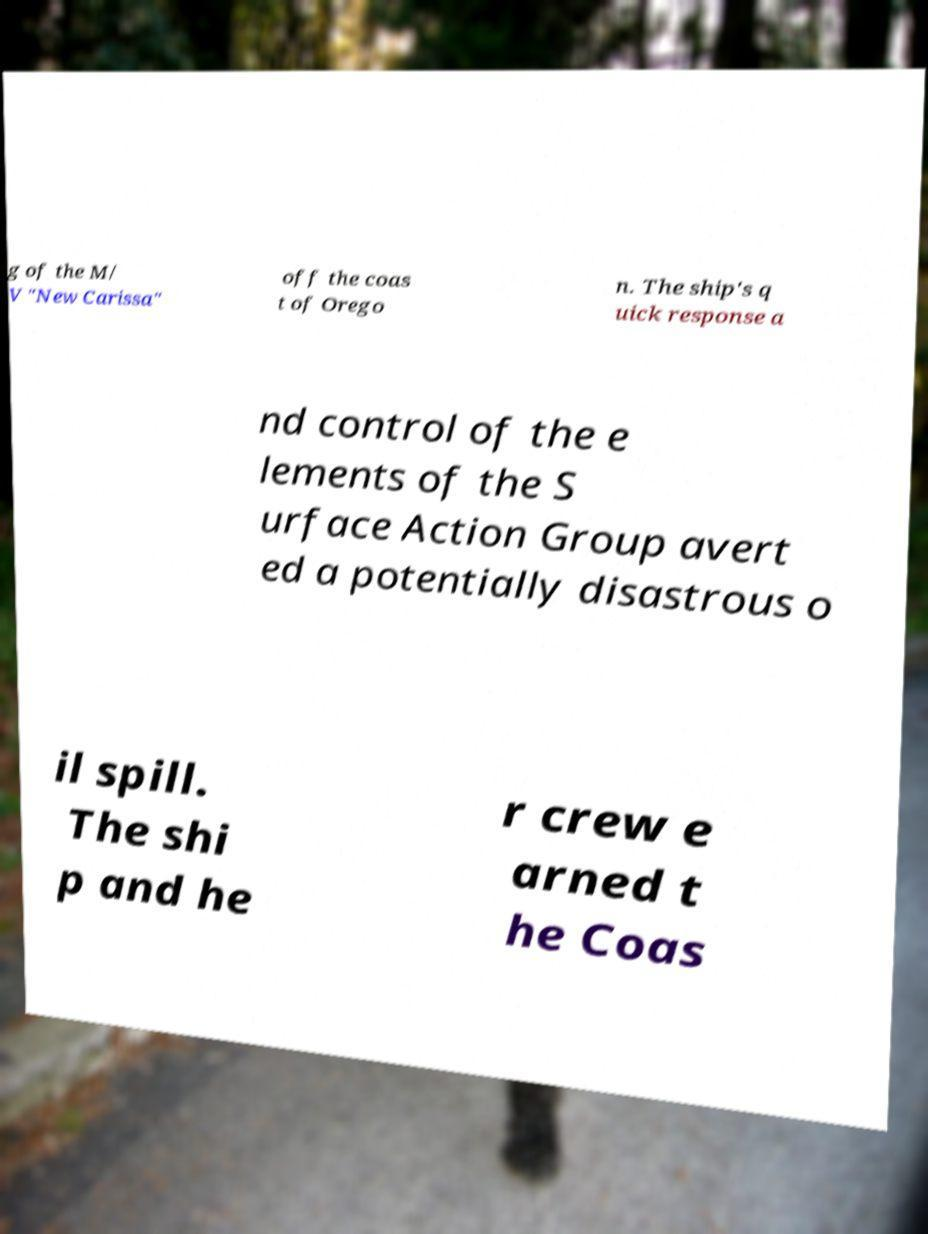Can you read and provide the text displayed in the image?This photo seems to have some interesting text. Can you extract and type it out for me? g of the M/ V "New Carissa" off the coas t of Orego n. The ship's q uick response a nd control of the e lements of the S urface Action Group avert ed a potentially disastrous o il spill. The shi p and he r crew e arned t he Coas 